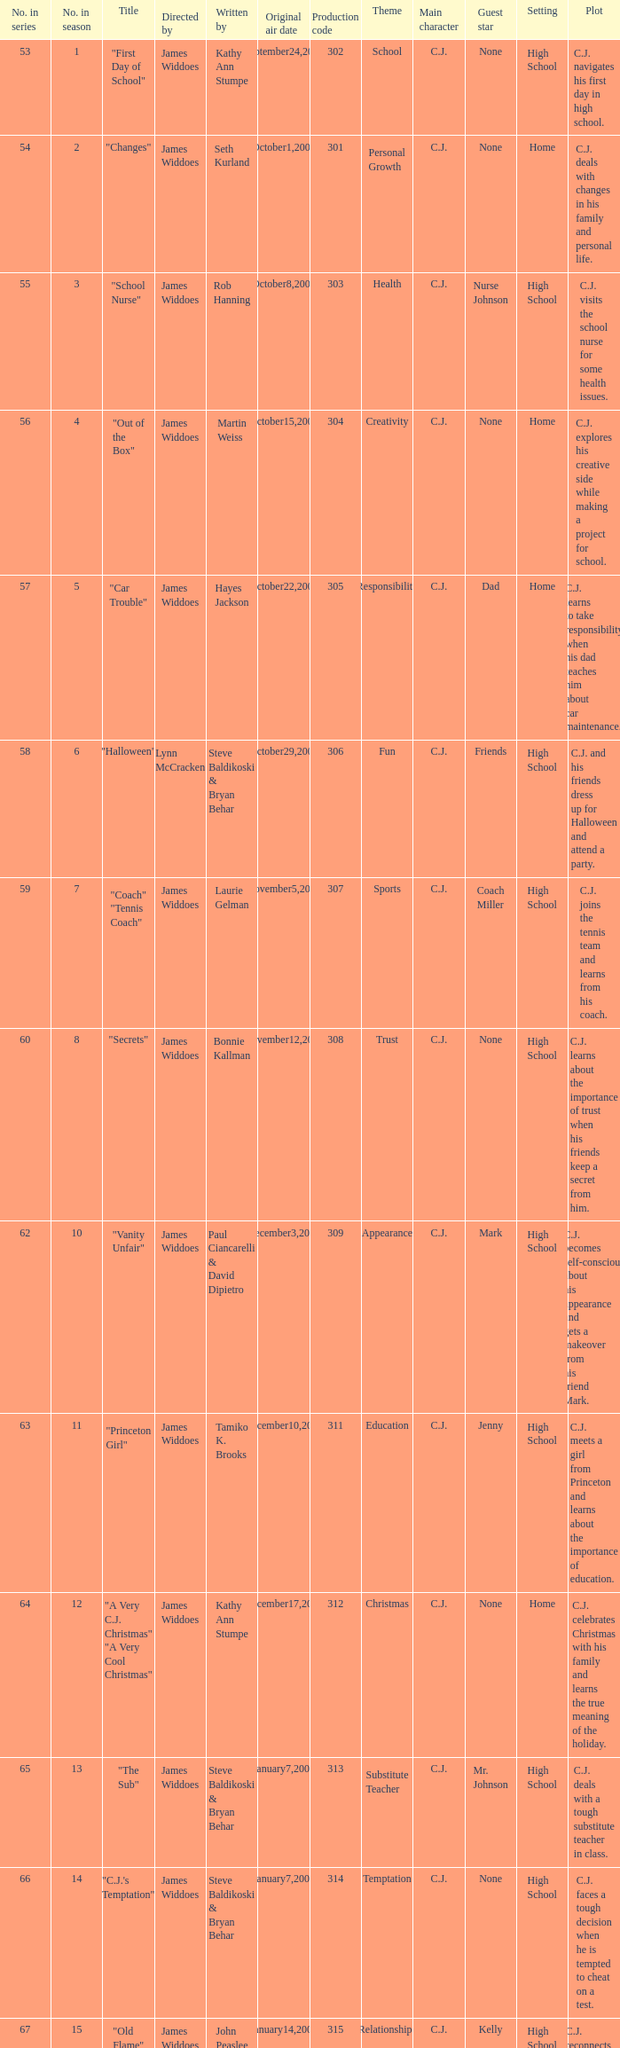What date was the episode originally aired that was directed by James Widdoes and the production code is 320? February18,2005. 